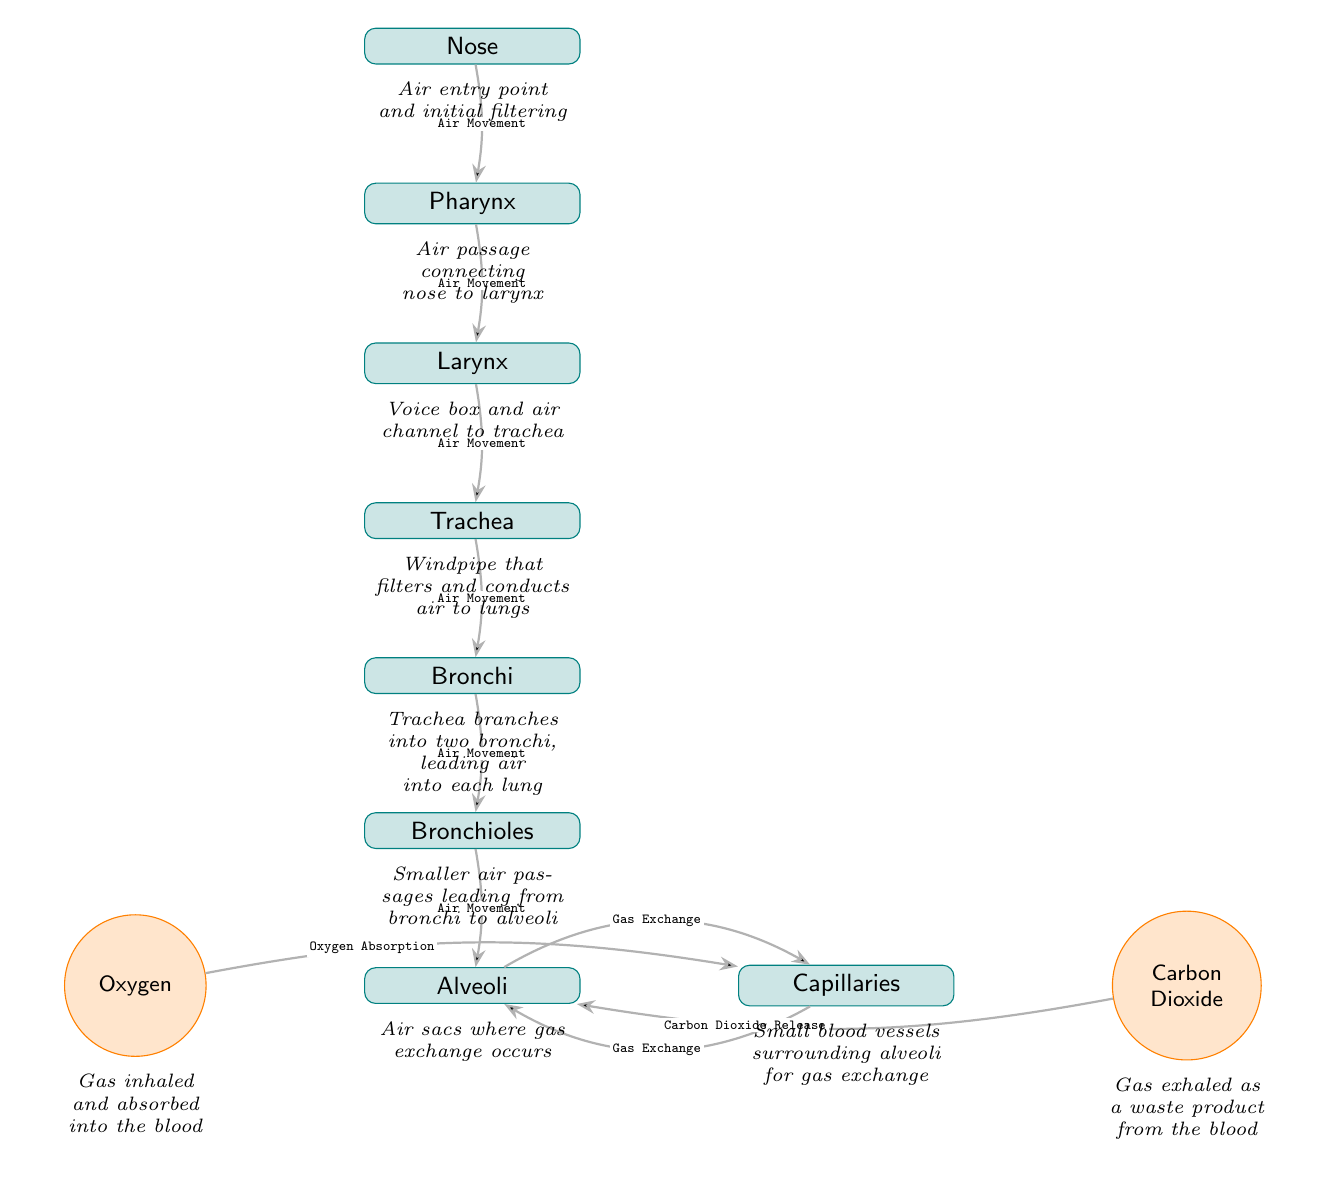What is the first organ in the airflow pathway? The diagram starts with the "Nose" as the initial point for air entry. Therefore, it is indicated as the first organ in the pathway of airflow.
Answer: Nose How many total organs are represented in the diagram? By counting each rectangular organ node in the diagram, we can identify there are a total of 8 organs depicted from the "Nose" to "Alveoli".
Answer: 8 What process occurs between the alveoli and capillaries? The label on the edge connecting the alveoli to the capillaries indicates "Gas Exchange", indicating the primary function of these structures in the respiratory system.
Answer: Gas Exchange What gas is absorbed into the capillaries? The diagram specifies "Oxygen" as the gas that is absorbed from the alveoli into the capillaries during the gas exchange process.
Answer: Oxygen What happens to carbon dioxide in the alveoli? The edge labeled "Carbon Dioxide Release" indicates that carbon dioxide is expelled from the capillaries into the alveoli for exhalation, highlighting its role as a waste product.
Answer: Carbon Dioxide Release Which organ connects the pharynx to the trachea? The "Larynx" is depicted directly beneath the "Pharynx" in the diagram, indicating it serves as the passageway connecting the two, thus facilitating the airflow.
Answer: Larynx Where does the airflow go after the bronchi? The airflow proceeds from the bronchi straight down to the bronchioles as indicated by the directed edge between them in the airflow pathway.
Answer: Bronchioles How does air enter the respiratory system? Air enters through the "Nose," which is explicitly marked as the point of entry in the diagram, identifiable at the topmost part of the airflow pathway.
Answer: Nose What is the role of the alveoli in the respiratory system? The diagram describes the "Alveoli" as "Air sacs where gas exchange occurs", indicating their primary function is to facilitate the exchange of gases in the bloodstream.
Answer: Gas exchange occurs What structure branches from the trachea? The "Bronchi" are illustrated as the divisions of the trachea, leading air into each lung, representing the next significant step in the airflow pathway.
Answer: Bronchi 